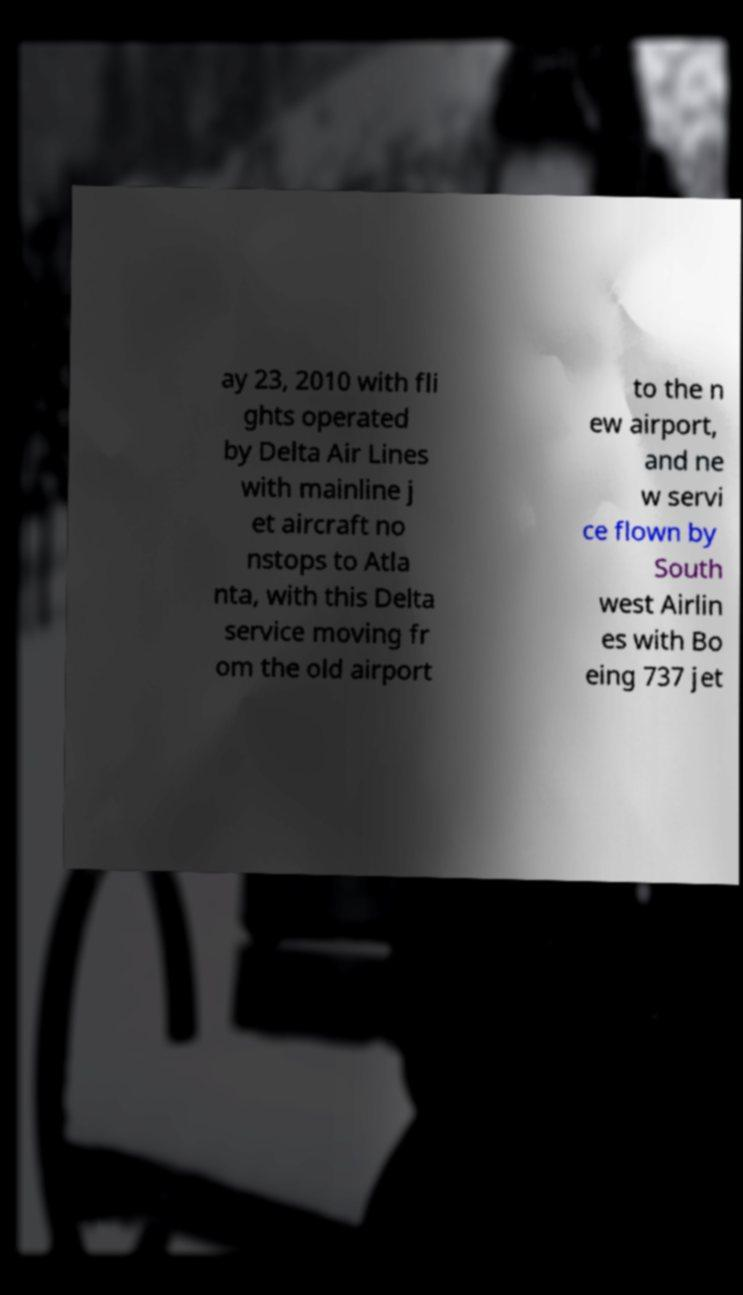Please identify and transcribe the text found in this image. ay 23, 2010 with fli ghts operated by Delta Air Lines with mainline j et aircraft no nstops to Atla nta, with this Delta service moving fr om the old airport to the n ew airport, and ne w servi ce flown by South west Airlin es with Bo eing 737 jet 